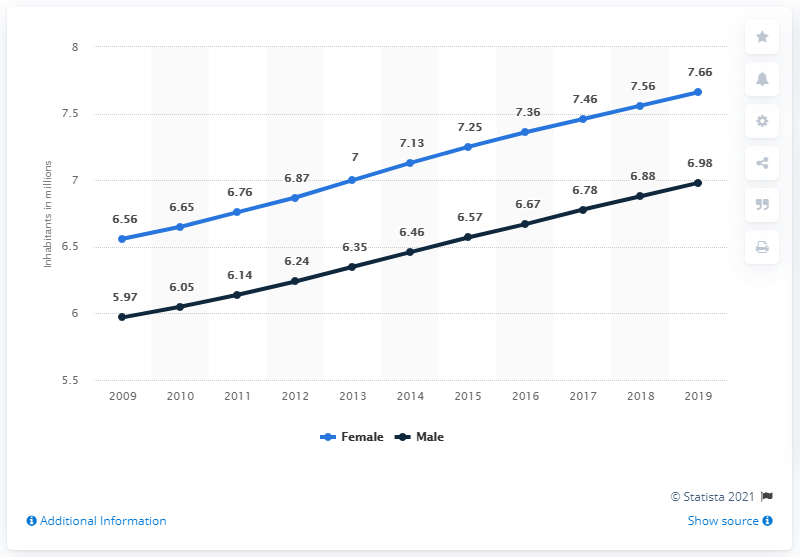Point out several critical features in this image. As of 2019, the male population of Zimbabwe was 6.98 million. According to estimates, in 2019, Zimbabwe had a female population of approximately 7.66 million. 